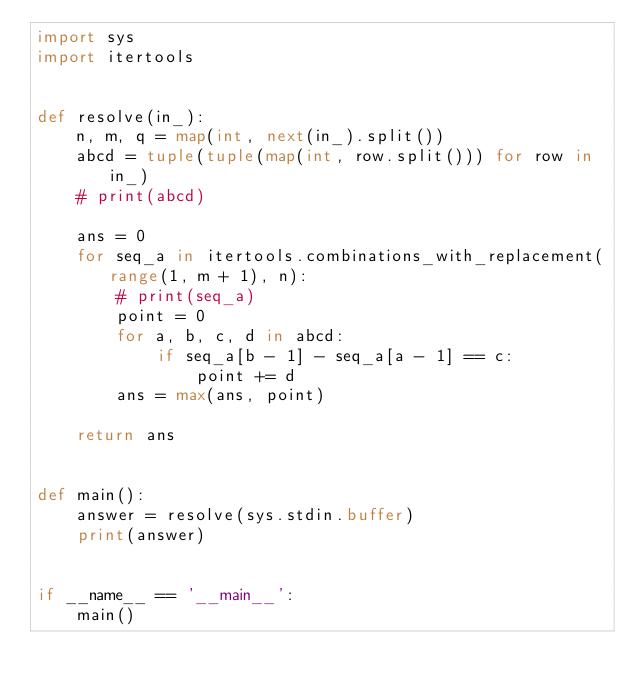<code> <loc_0><loc_0><loc_500><loc_500><_Python_>import sys
import itertools


def resolve(in_):
    n, m, q = map(int, next(in_).split())
    abcd = tuple(tuple(map(int, row.split())) for row in in_)
    # print(abcd)

    ans = 0
    for seq_a in itertools.combinations_with_replacement(range(1, m + 1), n):
        # print(seq_a)
        point = 0
        for a, b, c, d in abcd:
            if seq_a[b - 1] - seq_a[a - 1] == c:
                point += d
        ans = max(ans, point)

    return ans


def main():
    answer = resolve(sys.stdin.buffer)
    print(answer)


if __name__ == '__main__':
    main()</code> 